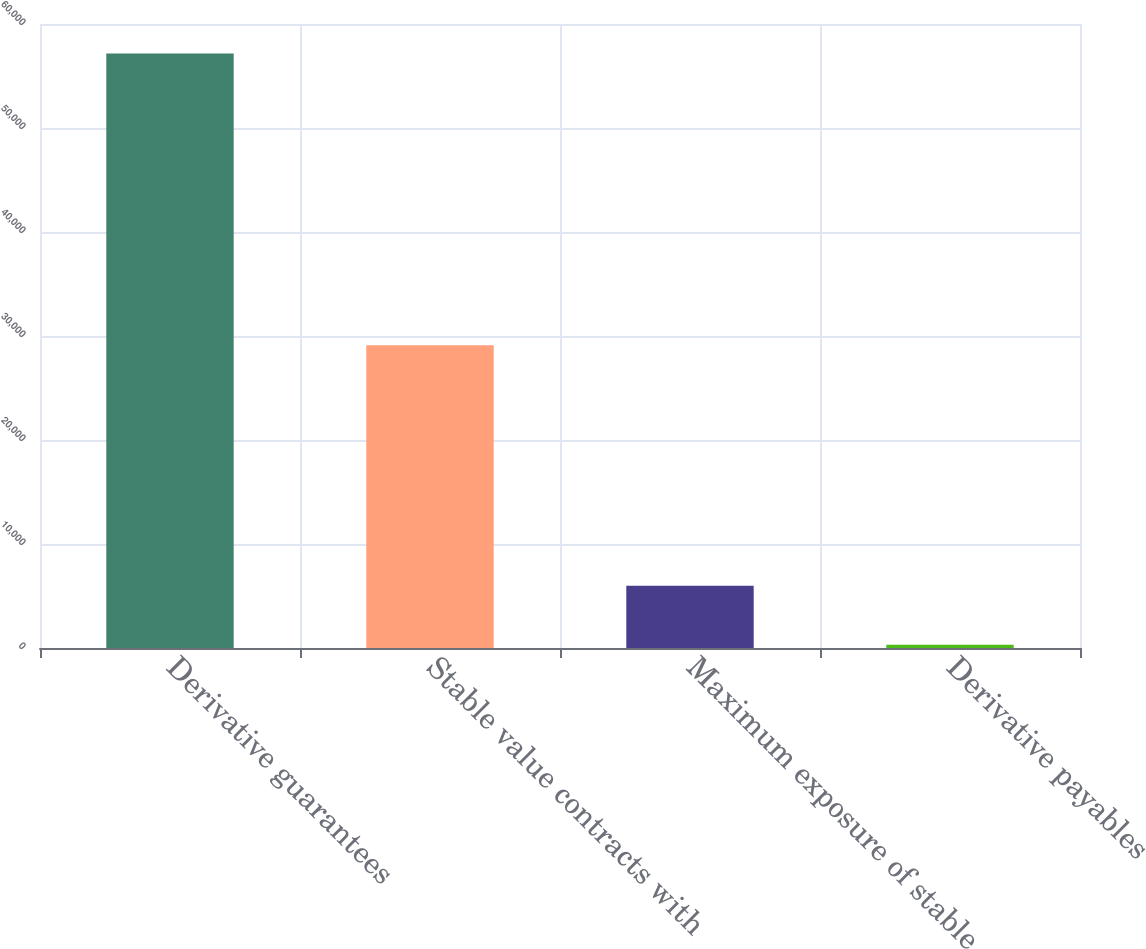Convert chart to OTSL. <chart><loc_0><loc_0><loc_500><loc_500><bar_chart><fcel>Derivative guarantees<fcel>Stable value contracts with<fcel>Maximum exposure of stable<fcel>Derivative payables<nl><fcel>57174<fcel>29104<fcel>5991<fcel>304<nl></chart> 